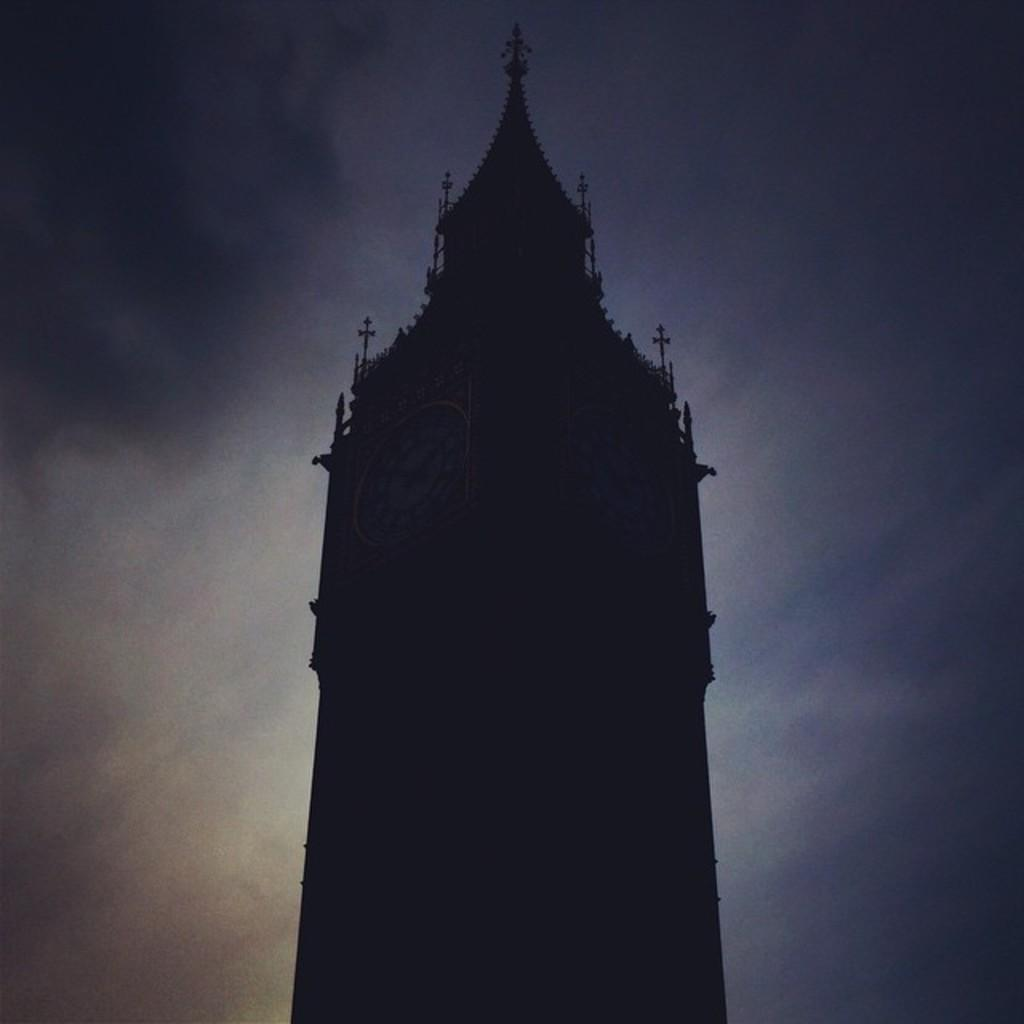What is the main subject of the picture? The main subject of the picture is a clock tower. Where is the clock tower located in the image? The clock tower is in the middle of the picture. What can be seen in the background of the image? The sky is visible in the background of the image. What is the color of the sky in the picture? The sky is blue in color. When was the picture taken, considering the lighting? The picture was clicked in the dark. What type of acoustics can be heard from the clock tower in the image? The image does not provide any information about the acoustics of the clock tower, so it cannot be determined from the picture. 